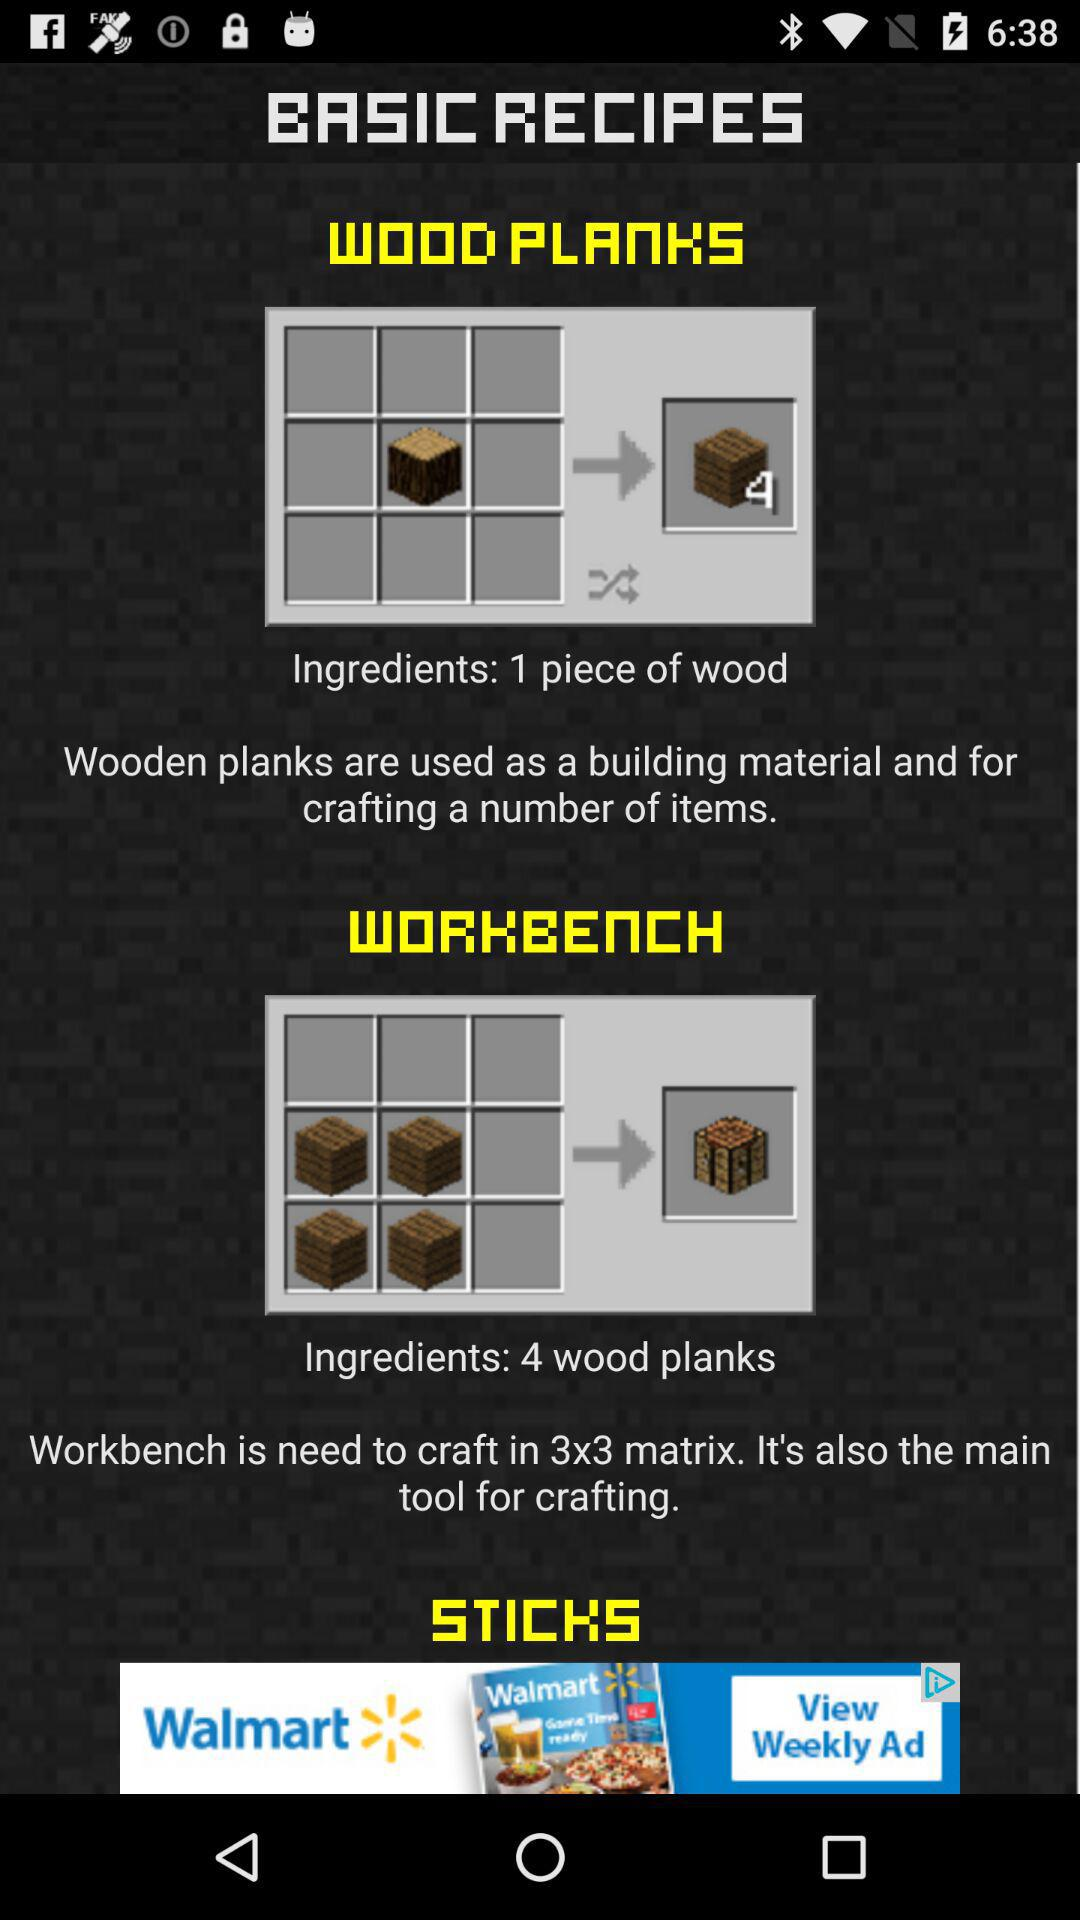What matrix is used for the workbench? The matrix used is "3x3". 